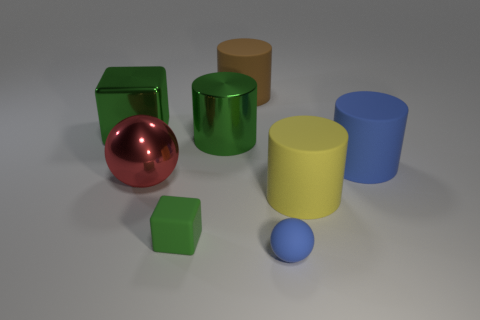Subtract all blue matte cylinders. How many cylinders are left? 3 Add 2 big yellow matte cylinders. How many objects exist? 10 Subtract all brown cylinders. How many cylinders are left? 3 Subtract all spheres. How many objects are left? 6 Subtract 3 cylinders. How many cylinders are left? 1 Subtract all red spheres. Subtract all yellow blocks. How many spheres are left? 1 Subtract all small matte cubes. Subtract all large green cylinders. How many objects are left? 6 Add 2 tiny matte cubes. How many tiny matte cubes are left? 3 Add 6 small blue spheres. How many small blue spheres exist? 7 Subtract 1 green cylinders. How many objects are left? 7 